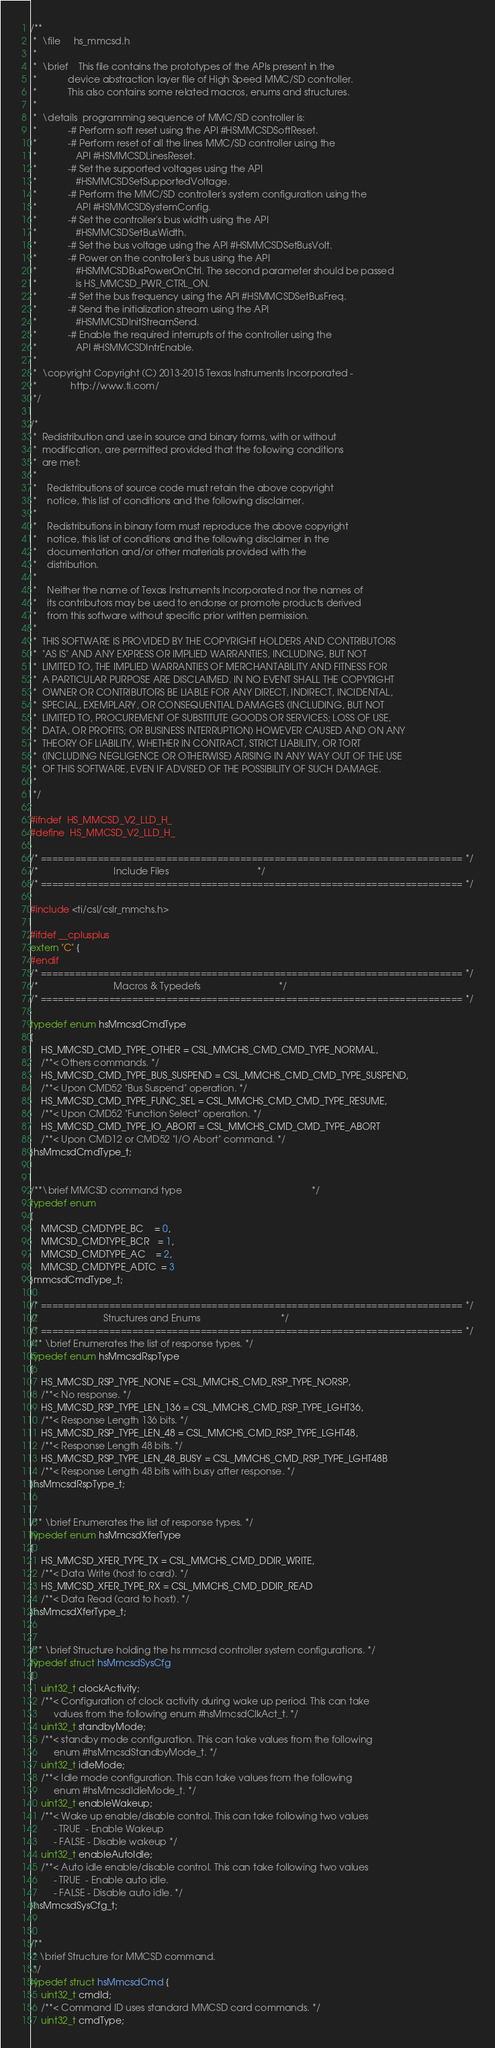Convert code to text. <code><loc_0><loc_0><loc_500><loc_500><_C_>/**
 *  \file     hs_mmcsd.h
 *
 *  \brief    This file contains the prototypes of the APIs present in the
 *            device abstraction layer file of High Speed MMC/SD controller.
 *            This also contains some related macros, enums and structures.
 *
 *  \details  programming sequence of MMC/SD controller is:
 *            -# Perform soft reset using the API #HSMMCSDSoftReset.
 *            -# Perform reset of all the lines MMC/SD controller using the
 *               API #HSMMCSDLinesReset.
 *            -# Set the supported voltages using the API
 *               #HSMMCSDSetSupportedVoltage.
 *            -# Perform the MMC/SD controller's system configuration using the
 *               API #HSMMCSDSystemConfig.
 *            -# Set the controller's bus width using the API
 *               #HSMMCSDSetBusWidth.
 *            -# Set the bus voltage using the API #HSMMCSDSetBusVolt.
 *            -# Power on the controller's bus using the API
 *               #HSMMCSDBusPowerOnCtrl. The second parameter should be passed
 *               is HS_MMCSD_PWR_CTRL_ON.
 *            -# Set the bus frequency using the API #HSMMCSDSetBusFreq.
 *            -# Send the initialization stream using the API
 *               #HSMMCSDInitStreamSend.
 *            -# Enable the required interrupts of the controller using the
 *               API #HSMMCSDIntrEnable.
 *
 *  \copyright Copyright (C) 2013-2015 Texas Instruments Incorporated -
 *             http://www.ti.com/
 */

/*
 *  Redistribution and use in source and binary forms, with or without
 *  modification, are permitted provided that the following conditions
 *  are met:
 *
 *    Redistributions of source code must retain the above copyright
 *    notice, this list of conditions and the following disclaimer.
 *
 *    Redistributions in binary form must reproduce the above copyright
 *    notice, this list of conditions and the following disclaimer in the
 *    documentation and/or other materials provided with the
 *    distribution.
 *
 *    Neither the name of Texas Instruments Incorporated nor the names of
 *    its contributors may be used to endorse or promote products derived
 *    from this software without specific prior written permission.
 *
 *  THIS SOFTWARE IS PROVIDED BY THE COPYRIGHT HOLDERS AND CONTRIBUTORS
 *  "AS IS" AND ANY EXPRESS OR IMPLIED WARRANTIES, INCLUDING, BUT NOT
 *  LIMITED TO, THE IMPLIED WARRANTIES OF MERCHANTABILITY AND FITNESS FOR
 *  A PARTICULAR PURPOSE ARE DISCLAIMED. IN NO EVENT SHALL THE COPYRIGHT
 *  OWNER OR CONTRIBUTORS BE LIABLE FOR ANY DIRECT, INDIRECT, INCIDENTAL,
 *  SPECIAL, EXEMPLARY, OR CONSEQUENTIAL DAMAGES (INCLUDING, BUT NOT
 *  LIMITED TO, PROCUREMENT OF SUBSTITUTE GOODS OR SERVICES; LOSS OF USE,
 *  DATA, OR PROFITS; OR BUSINESS INTERRUPTION) HOWEVER CAUSED AND ON ANY
 *  THEORY OF LIABILITY, WHETHER IN CONTRACT, STRICT LIABILITY, OR TORT
 *  (INCLUDING NEGLIGENCE OR OTHERWISE) ARISING IN ANY WAY OUT OF THE USE
 *  OF THIS SOFTWARE, EVEN IF ADVISED OF THE POSSIBILITY OF SUCH DAMAGE.
 *
 */

#ifndef  HS_MMCSD_V2_LLD_H_
#define  HS_MMCSD_V2_LLD_H_

/* ========================================================================== */
/*                             Include Files                                  */
/* ========================================================================== */

#include <ti/csl/cslr_mmchs.h>

#ifdef __cplusplus
extern "C" {
#endif
/* ========================================================================== */
/*                             Macros & Typedefs                              */
/* ========================================================================== */

typedef enum hsMmcsdCmdType
{
    HS_MMCSD_CMD_TYPE_OTHER = CSL_MMCHS_CMD_CMD_TYPE_NORMAL,
    /**< Others commands. */
    HS_MMCSD_CMD_TYPE_BUS_SUSPEND = CSL_MMCHS_CMD_CMD_TYPE_SUSPEND,
    /**< Upon CMD52 "Bus Suspend" operation. */
    HS_MMCSD_CMD_TYPE_FUNC_SEL = CSL_MMCHS_CMD_CMD_TYPE_RESUME,
    /**< Upon CMD52 "Function Select" operation. */
    HS_MMCSD_CMD_TYPE_IO_ABORT = CSL_MMCHS_CMD_CMD_TYPE_ABORT
    /**< Upon CMD12 or CMD52 "I/O Abort" command. */
}hsMmcsdCmdType_t;


/**\brief MMCSD command type                                                  */
typedef enum
{
    MMCSD_CMDTYPE_BC    = 0,
    MMCSD_CMDTYPE_BCR   = 1,
    MMCSD_CMDTYPE_AC    = 2,
    MMCSD_CMDTYPE_ADTC  = 3
}mmcsdCmdType_t;

/* ========================================================================== */
/*                         Structures and Enums                               */
/* ========================================================================== */
/** \brief Enumerates the list of response types. */
typedef enum hsMmcsdRspType
{
    HS_MMCSD_RSP_TYPE_NONE = CSL_MMCHS_CMD_RSP_TYPE_NORSP,
    /**< No response. */
    HS_MMCSD_RSP_TYPE_LEN_136 = CSL_MMCHS_CMD_RSP_TYPE_LGHT36,
    /**< Response Length 136 bits. */
    HS_MMCSD_RSP_TYPE_LEN_48 = CSL_MMCHS_CMD_RSP_TYPE_LGHT48,
    /**< Response Length 48 bits. */
    HS_MMCSD_RSP_TYPE_LEN_48_BUSY = CSL_MMCHS_CMD_RSP_TYPE_LGHT48B
    /**< Response Length 48 bits with busy after response. */
}hsMmcsdRspType_t;


/** \brief Enumerates the list of response types. */
typedef enum hsMmcsdXferType
{
    HS_MMCSD_XFER_TYPE_TX = CSL_MMCHS_CMD_DDIR_WRITE,
    /**< Data Write (host to card). */
    HS_MMCSD_XFER_TYPE_RX = CSL_MMCHS_CMD_DDIR_READ
    /**< Data Read (card to host). */
}hsMmcsdXferType_t;


/** \brief Structure holding the hs mmcsd controller system configurations. */
typedef struct hsMmcsdSysCfg
{
    uint32_t clockActivity;
    /**< Configuration of clock activity during wake up period. This can take
         values from the following enum #hsMmcsdClkAct_t. */
    uint32_t standbyMode;
    /**< standby mode configuration. This can take values from the following
         enum #hsMmcsdStandbyMode_t. */
    uint32_t idleMode;
    /**< Idle mode configuration. This can take values from the following
         enum #hsMmcsdIdleMode_t. */
    uint32_t enableWakeup;
    /**< Wake up enable/disable control. This can take following two values
         - TRUE  - Enable Wakeup
         - FALSE - Disable wakeup */
    uint32_t enableAutoIdle;
    /**< Auto idle enable/disable control. This can take following two values
         - TRUE  - Enable auto idle.
         - FALSE - Disable auto idle. */
}hsMmcsdSysCfg_t;


/**
 * \brief Structure for MMCSD command.
 */
typedef struct hsMmcsdCmd {
    uint32_t cmdId;
    /**< Command ID uses standard MMCSD card commands. */
    uint32_t cmdType;</code> 